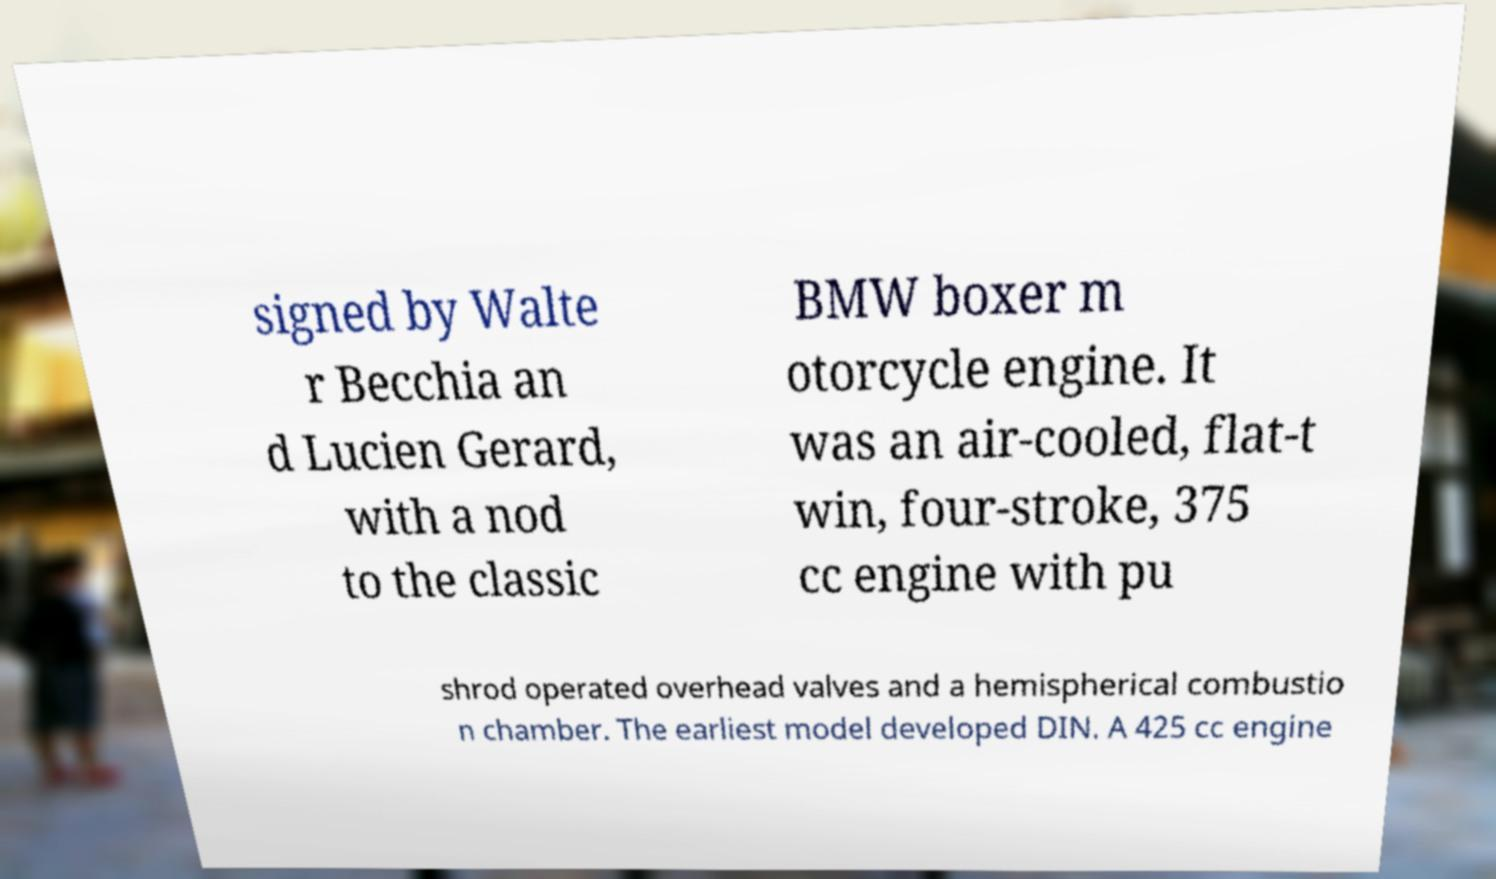Could you extract and type out the text from this image? signed by Walte r Becchia an d Lucien Gerard, with a nod to the classic BMW boxer m otorcycle engine. It was an air-cooled, flat-t win, four-stroke, 375 cc engine with pu shrod operated overhead valves and a hemispherical combustio n chamber. The earliest model developed DIN. A 425 cc engine 